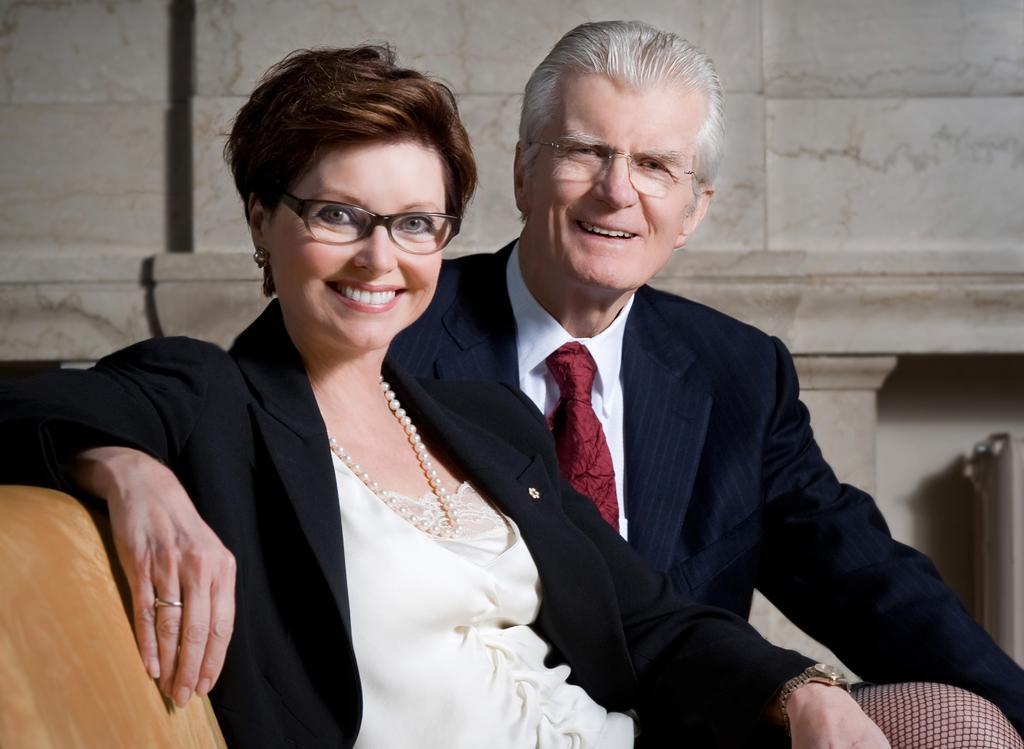Can you describe this image briefly? In this image we can see a man and a woman sitting on a sofa. On the backside we can see a wall. 